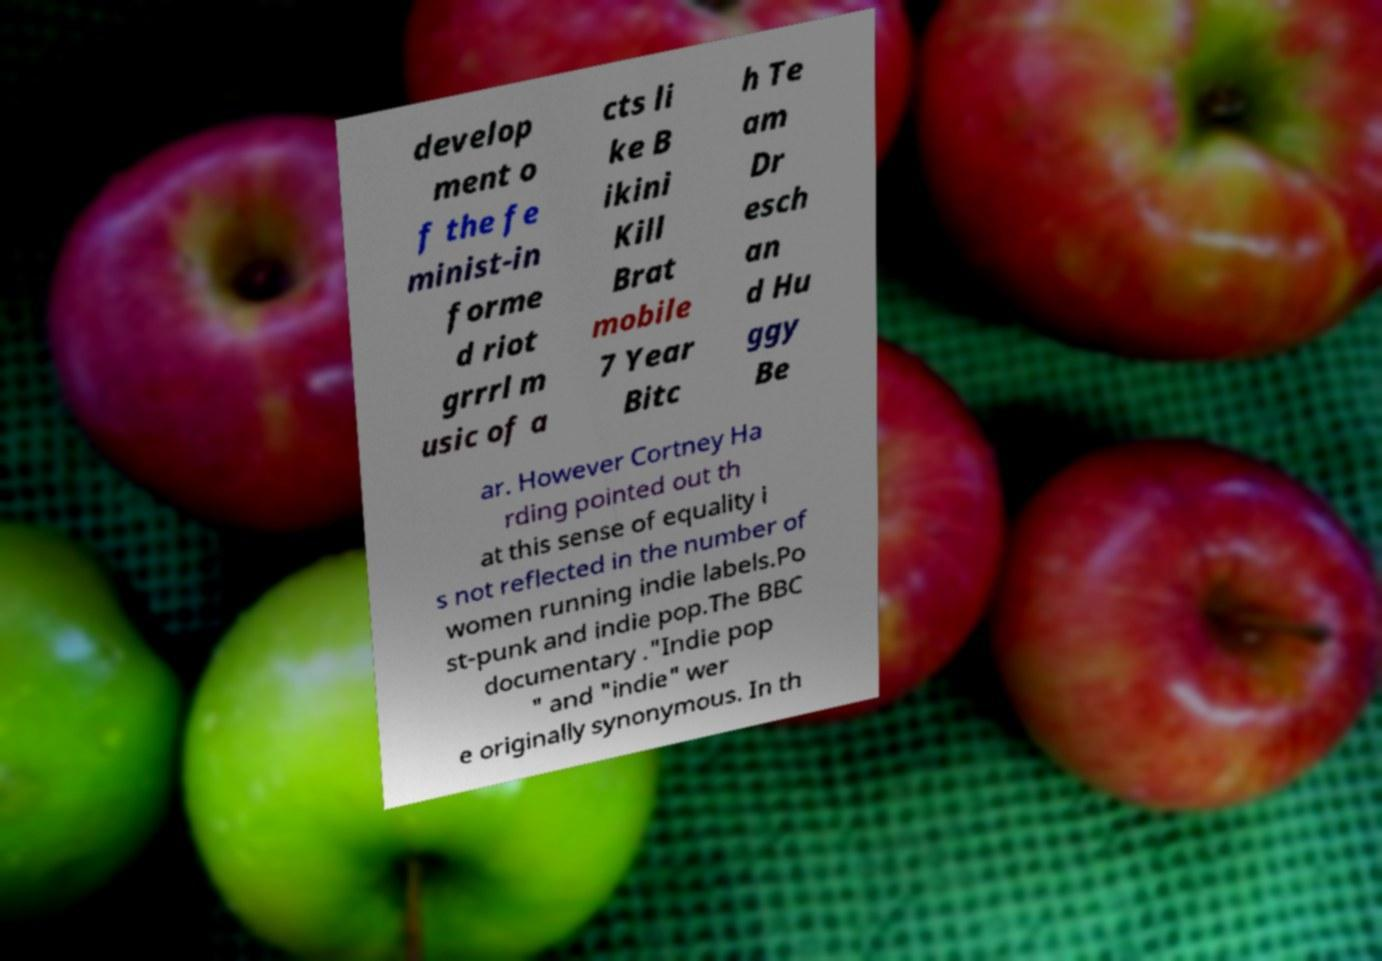Could you extract and type out the text from this image? develop ment o f the fe minist-in forme d riot grrrl m usic of a cts li ke B ikini Kill Brat mobile 7 Year Bitc h Te am Dr esch an d Hu ggy Be ar. However Cortney Ha rding pointed out th at this sense of equality i s not reflected in the number of women running indie labels.Po st-punk and indie pop.The BBC documentary ."Indie pop " and "indie" wer e originally synonymous. In th 